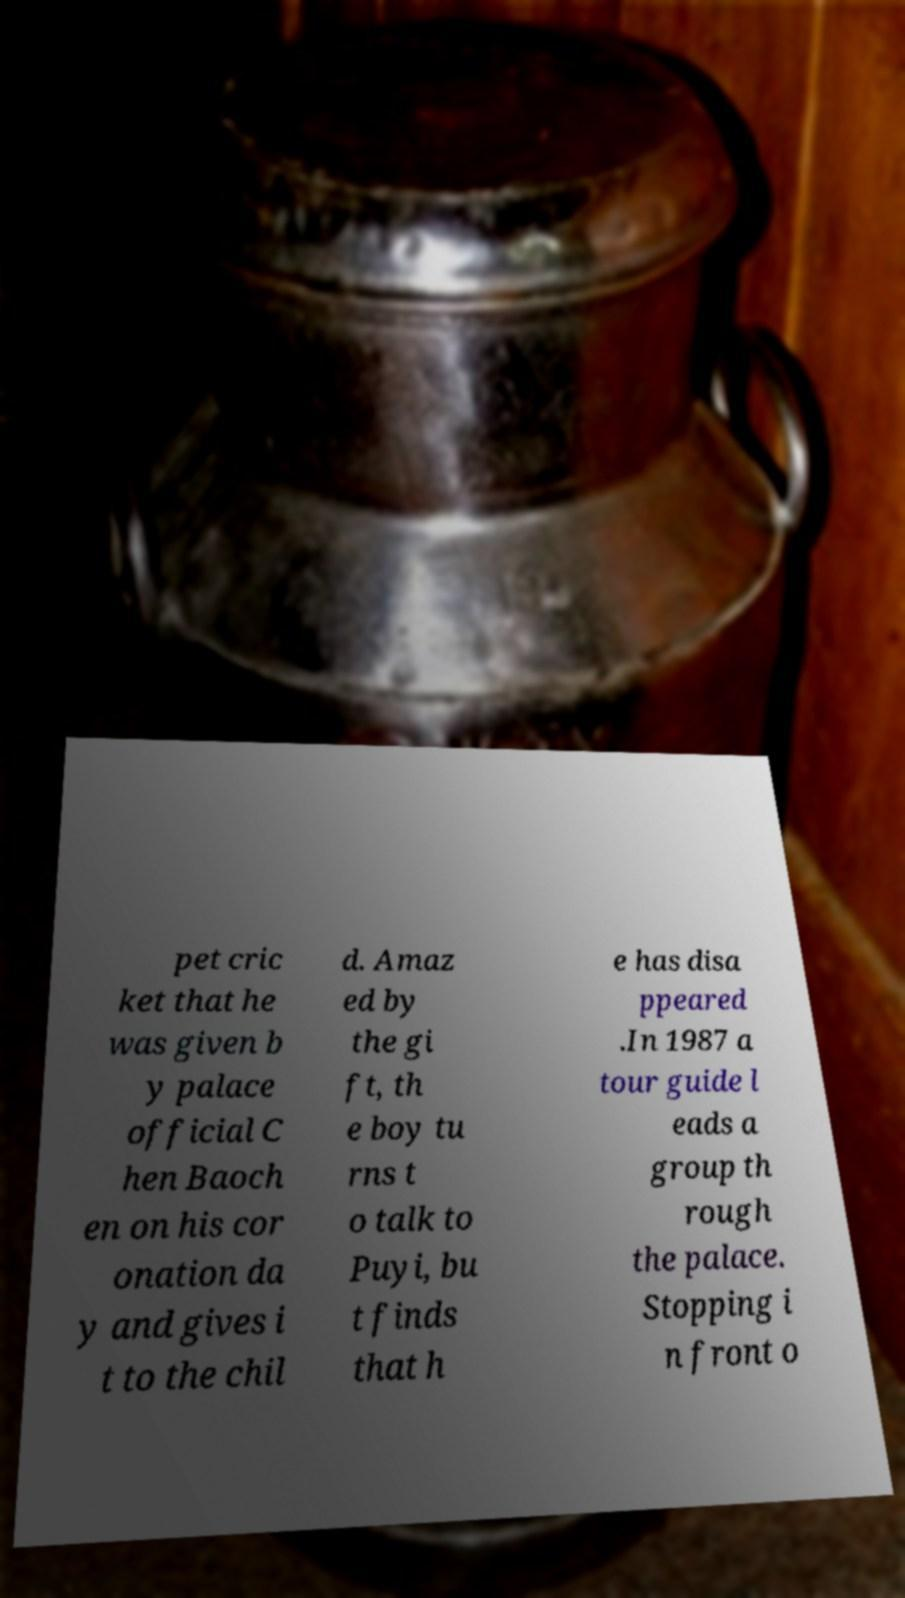There's text embedded in this image that I need extracted. Can you transcribe it verbatim? pet cric ket that he was given b y palace official C hen Baoch en on his cor onation da y and gives i t to the chil d. Amaz ed by the gi ft, th e boy tu rns t o talk to Puyi, bu t finds that h e has disa ppeared .In 1987 a tour guide l eads a group th rough the palace. Stopping i n front o 